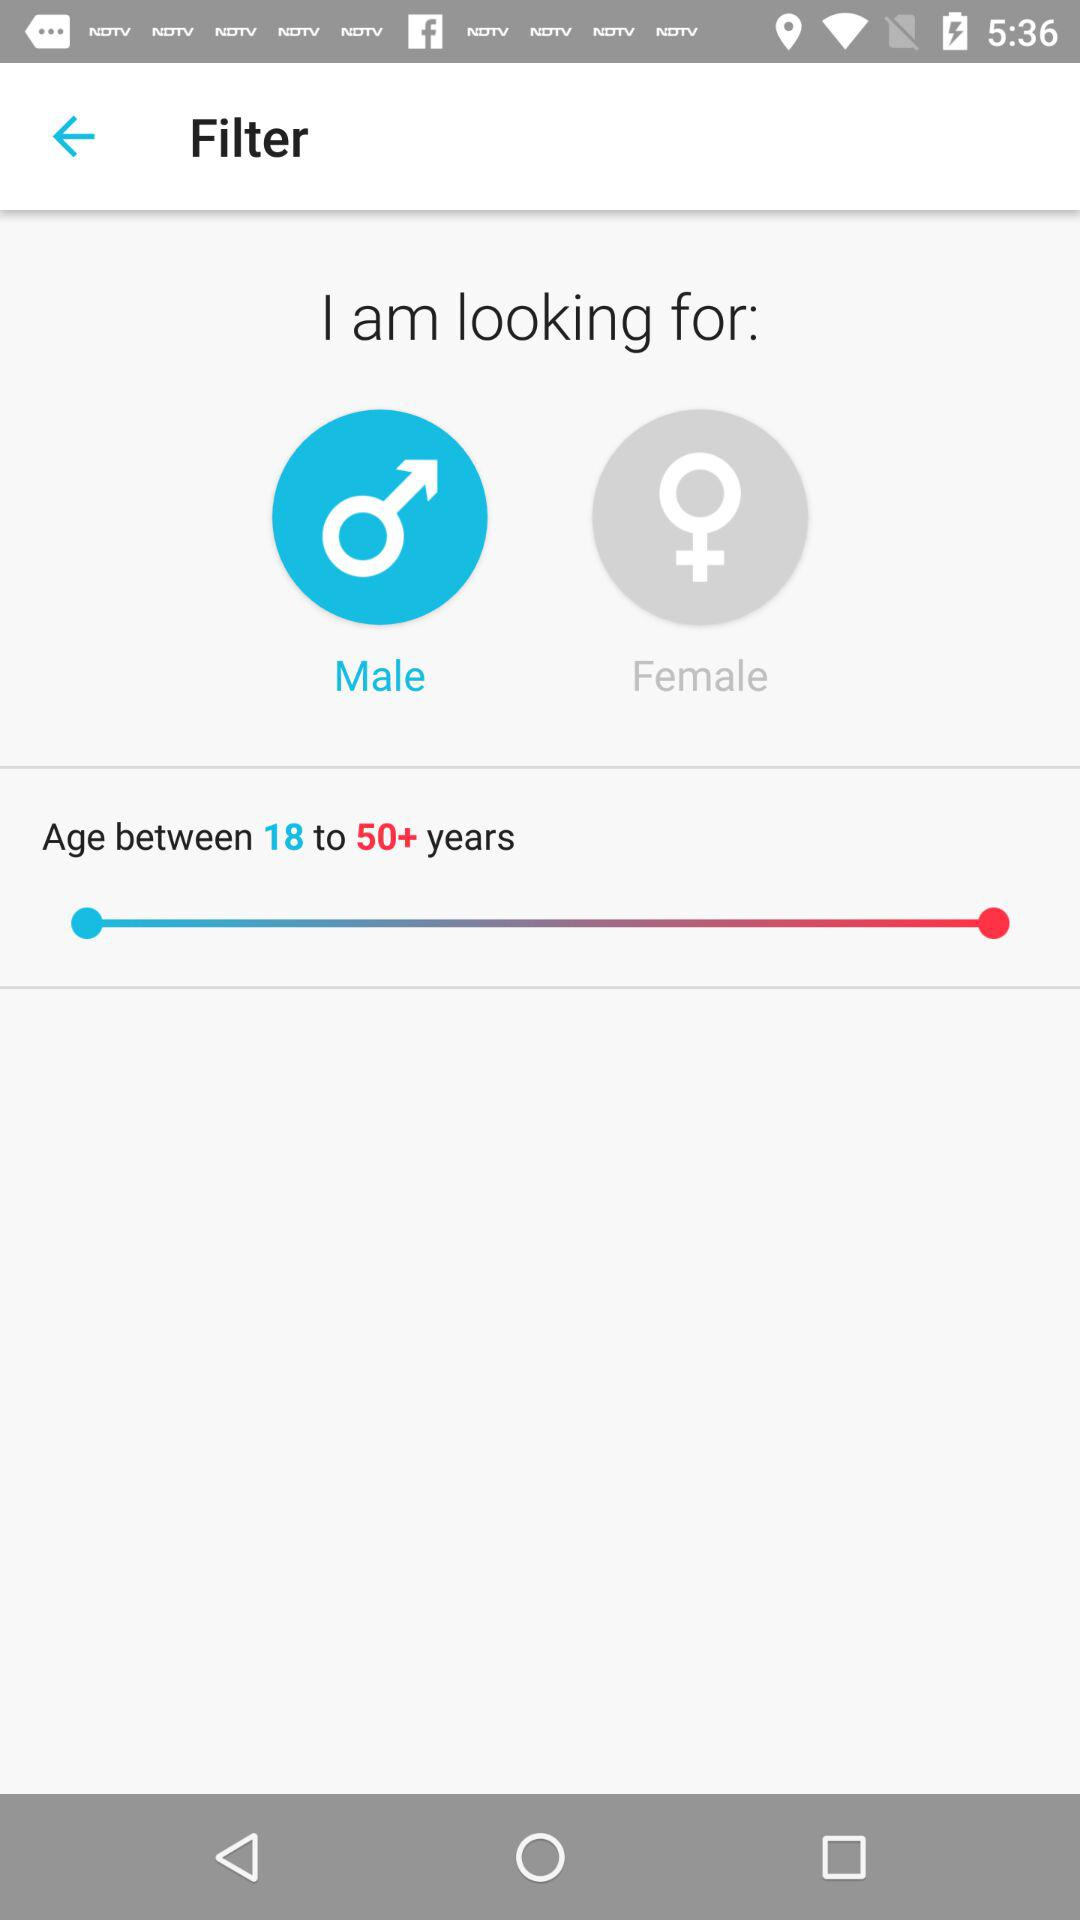What is the given age range? The given age range is 18 to 50+ years. 